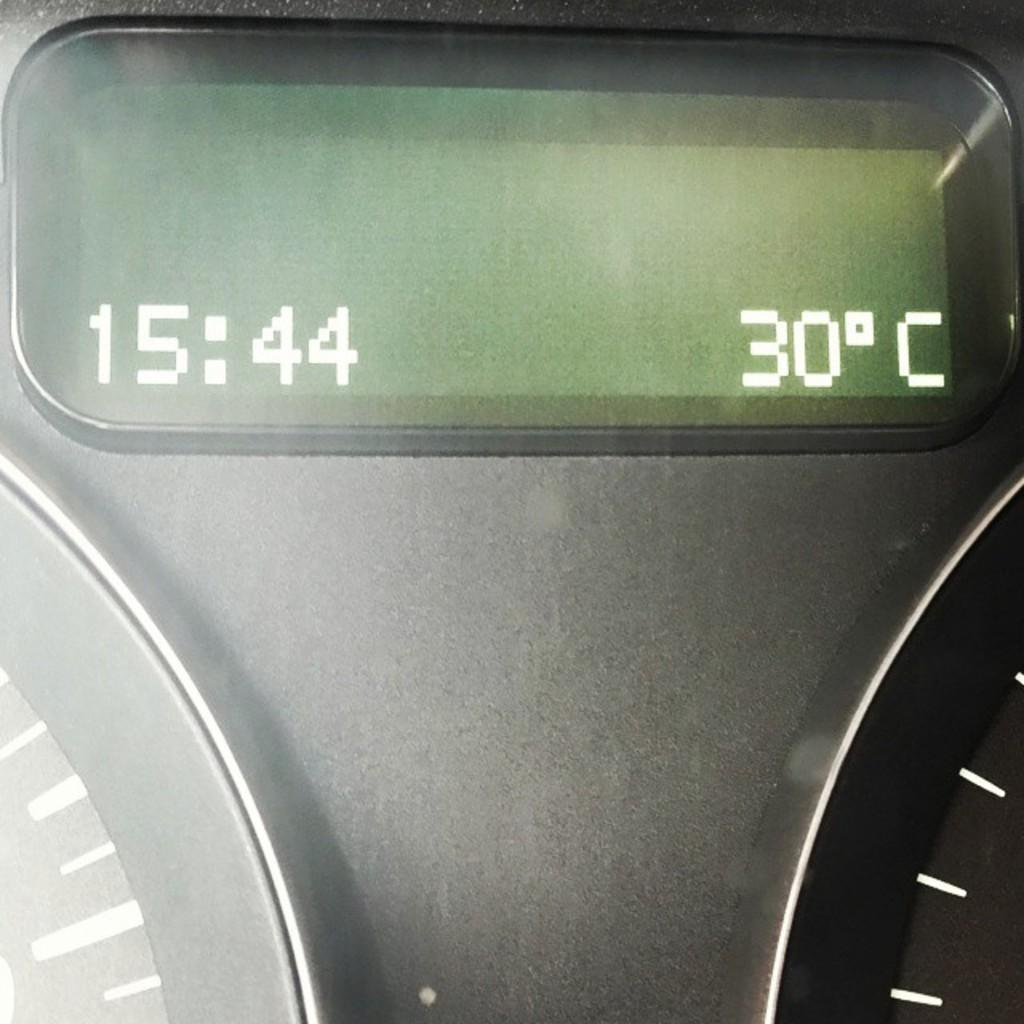<image>
Summarize the visual content of the image. a display of time and temperature on a car dashboard, with the time being 15:44 and the temp being 30C 